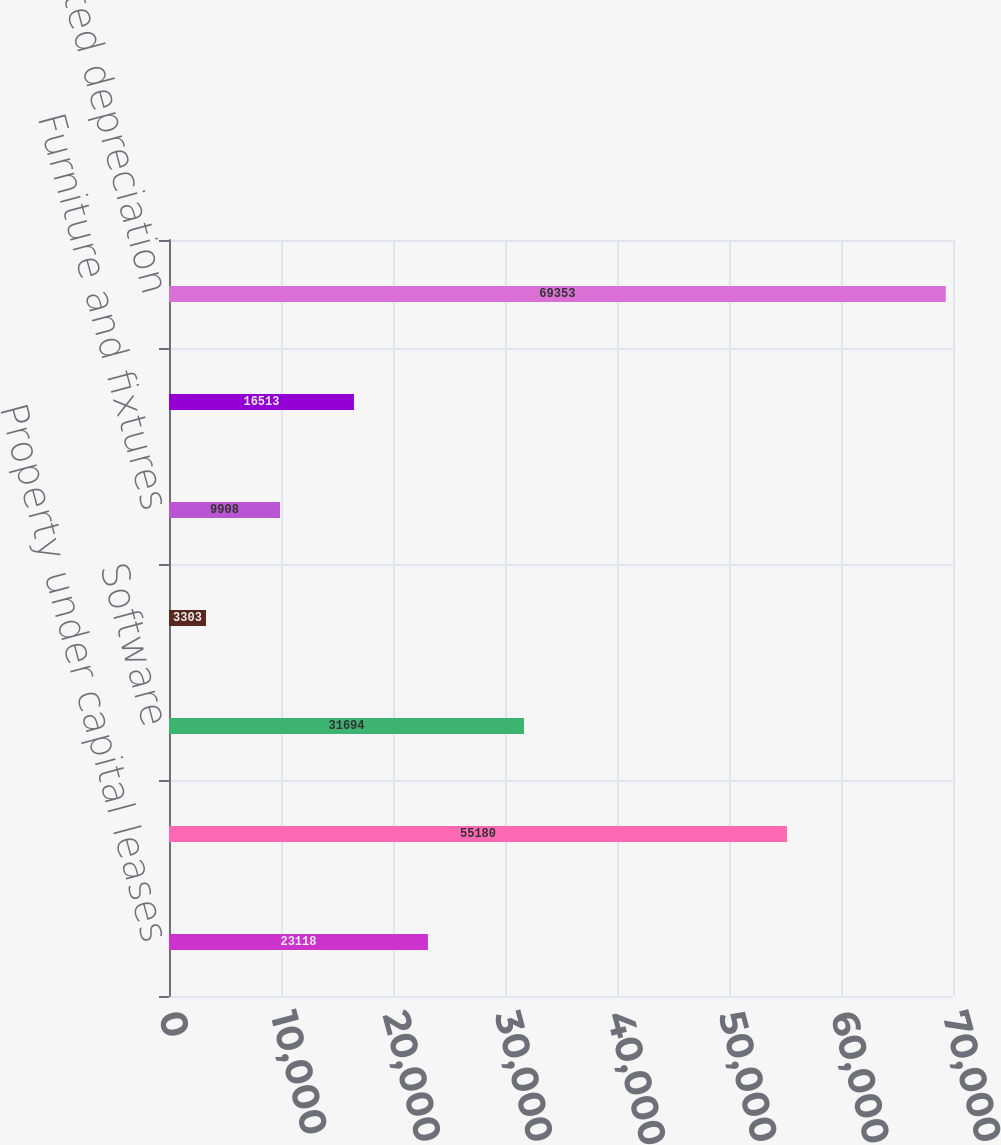Convert chart. <chart><loc_0><loc_0><loc_500><loc_500><bar_chart><fcel>Property under capital leases<fcel>Equipment<fcel>Software<fcel>Leasehold improvements<fcel>Furniture and fixtures<fcel>Work in progress<fcel>Less accumulated depreciation<nl><fcel>23118<fcel>55180<fcel>31694<fcel>3303<fcel>9908<fcel>16513<fcel>69353<nl></chart> 